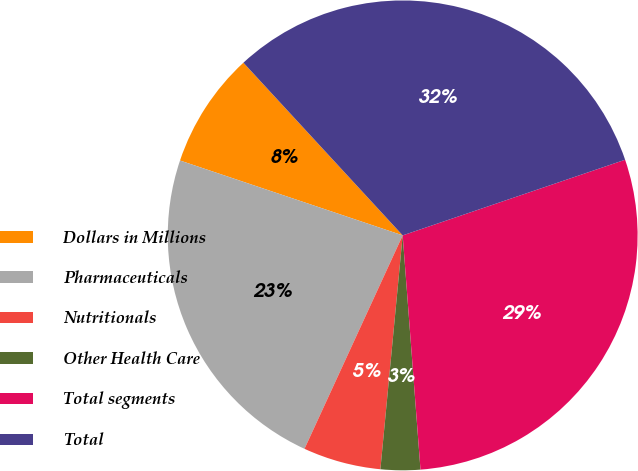<chart> <loc_0><loc_0><loc_500><loc_500><pie_chart><fcel>Dollars in Millions<fcel>Pharmaceuticals<fcel>Nutritionals<fcel>Other Health Care<fcel>Total segments<fcel>Total<nl><fcel>7.98%<fcel>23.3%<fcel>5.35%<fcel>2.72%<fcel>29.01%<fcel>31.64%<nl></chart> 